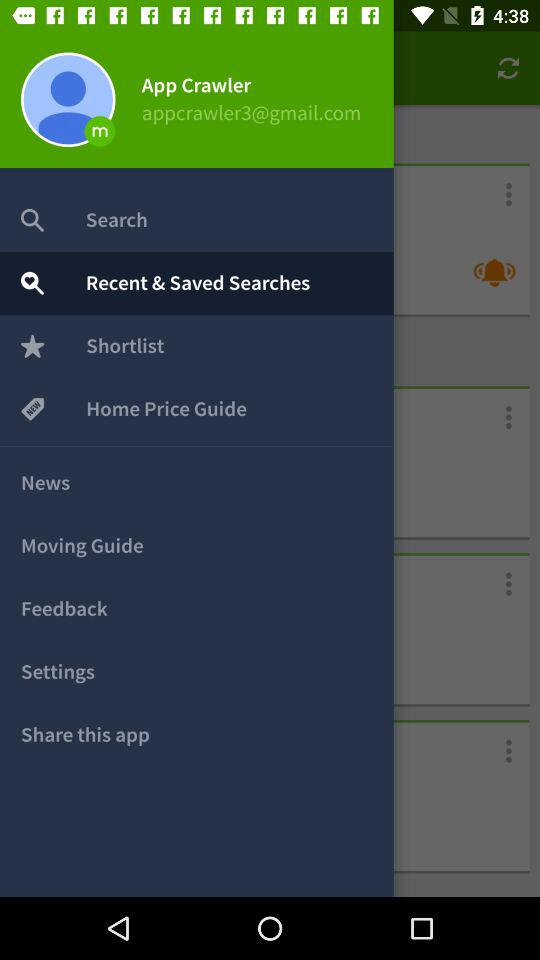Which item is selected in the menu? The selected item is "Recent & Saved Searches". 